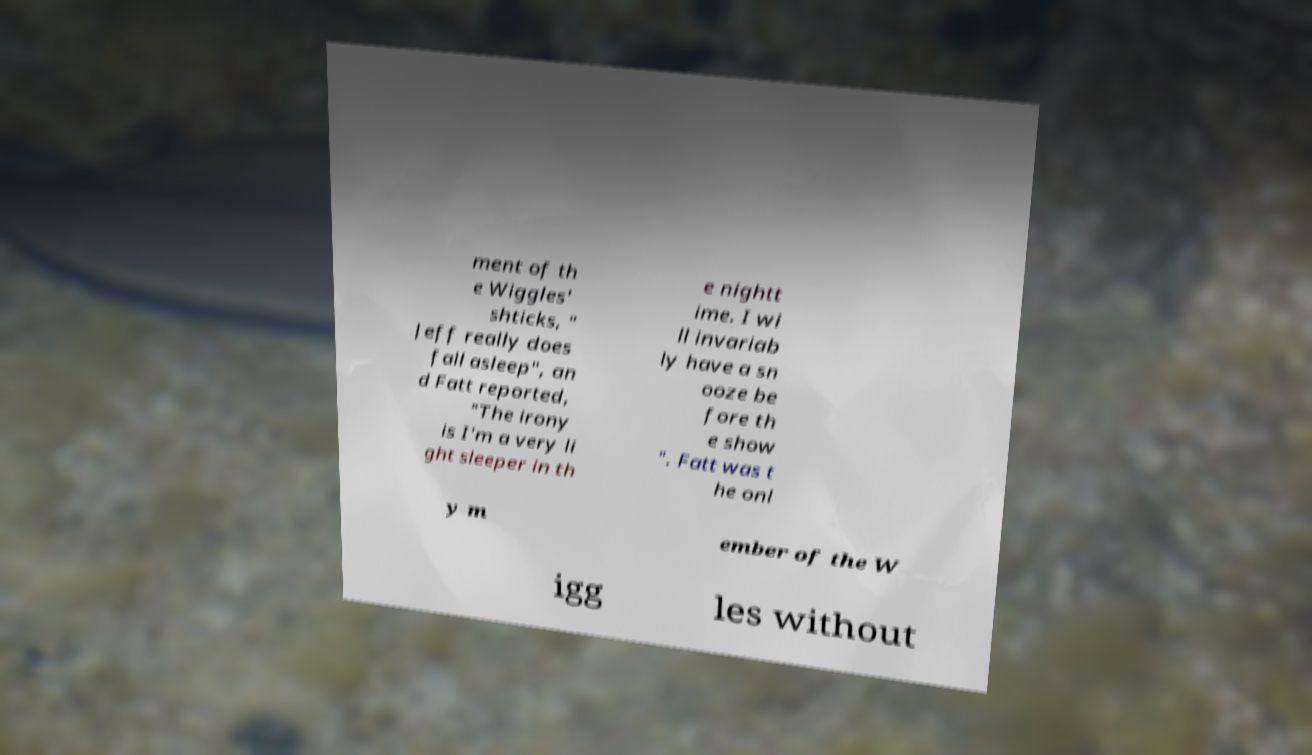Please identify and transcribe the text found in this image. ment of th e Wiggles' shticks, " Jeff really does fall asleep", an d Fatt reported, "The irony is I'm a very li ght sleeper in th e nightt ime. I wi ll invariab ly have a sn ooze be fore th e show ". Fatt was t he onl y m ember of the W igg les without 